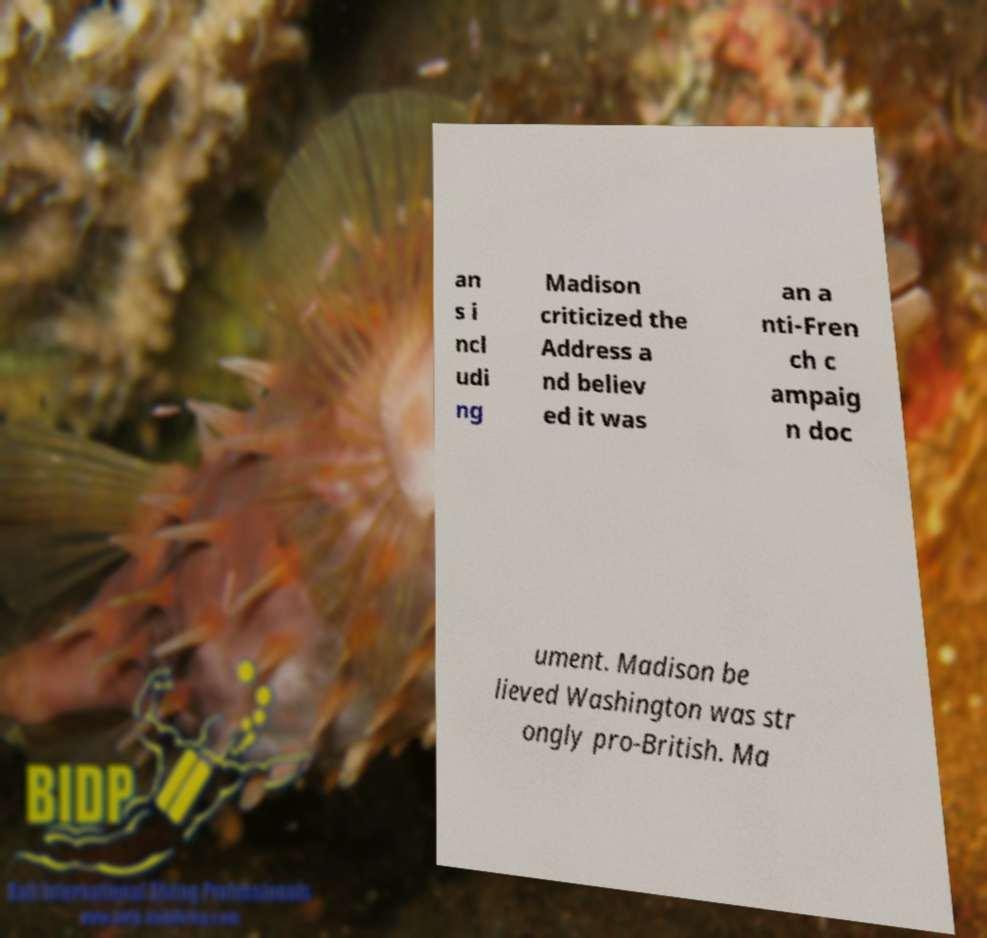Please read and relay the text visible in this image. What does it say? an s i ncl udi ng Madison criticized the Address a nd believ ed it was an a nti-Fren ch c ampaig n doc ument. Madison be lieved Washington was str ongly pro-British. Ma 